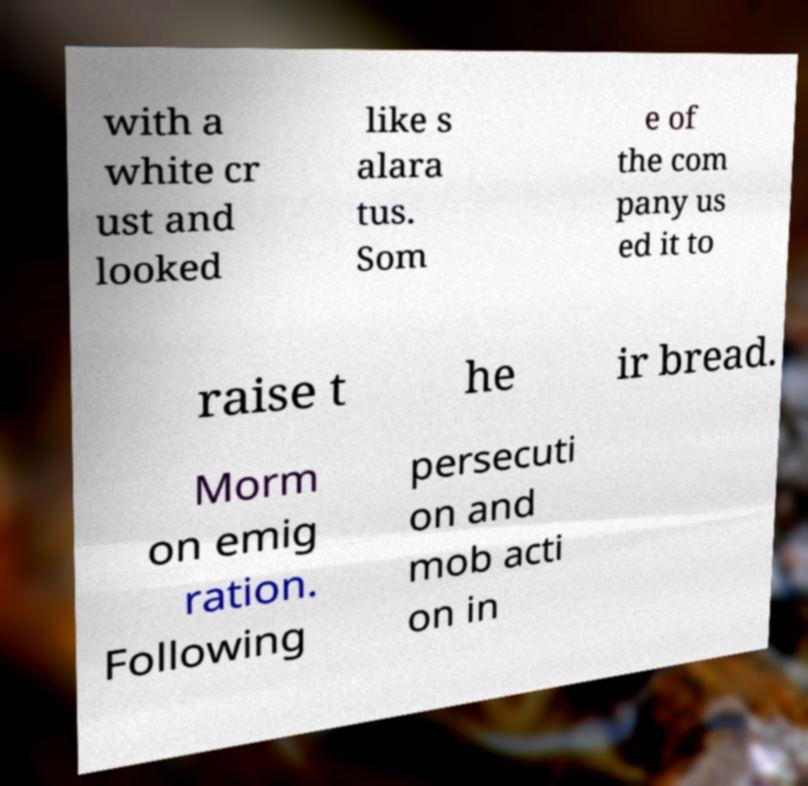Could you extract and type out the text from this image? with a white cr ust and looked like s alara tus. Som e of the com pany us ed it to raise t he ir bread. Morm on emig ration. Following persecuti on and mob acti on in 